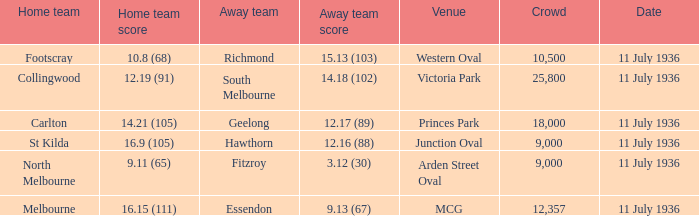What visiting team obtained a team score of 1 Hawthorn. 